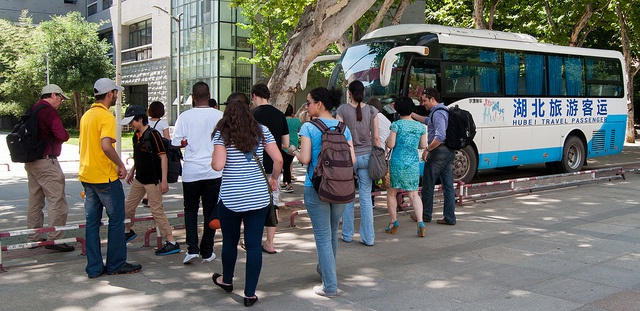Describe the objects in this image and their specific colors. I can see bus in gray, black, lightgray, and blue tones, people in gray, black, lavender, and blue tones, people in gray, black, and blue tones, people in gray, black, orange, and navy tones, and people in gray, black, lavender, and darkgray tones in this image. 